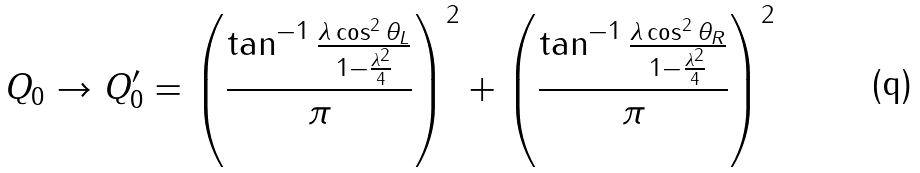Convert formula to latex. <formula><loc_0><loc_0><loc_500><loc_500>Q _ { 0 } \rightarrow Q _ { 0 } ^ { \prime } = \left ( \frac { \tan ^ { - 1 } { \frac { \lambda \cos ^ { 2 } \theta _ { L } } { 1 - \frac { \lambda ^ { 2 } } { 4 } } } } { \pi } \right ) ^ { 2 } + \left ( \frac { \tan ^ { - 1 } { \frac { \lambda \cos ^ { 2 } \theta _ { R } } { 1 - \frac { \lambda ^ { 2 } } { 4 } } } } { \pi } \right ) ^ { 2 }</formula> 